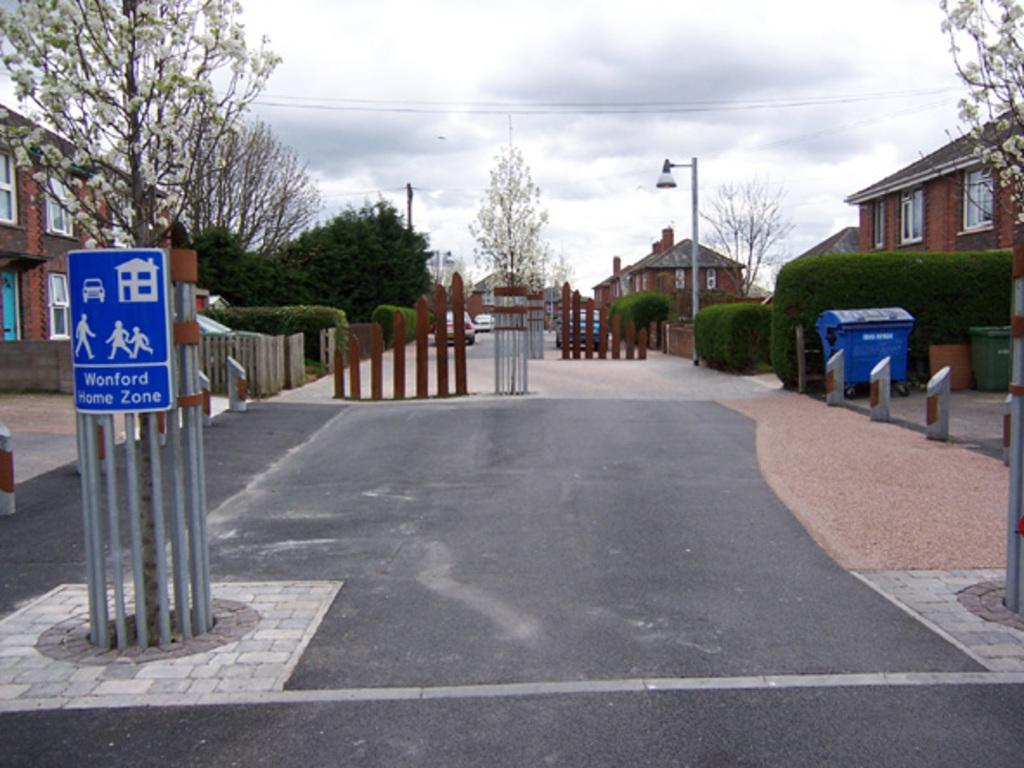<image>
Give a short and clear explanation of the subsequent image. A blue sign with people on it is labeled the Wonford Home Zone. 